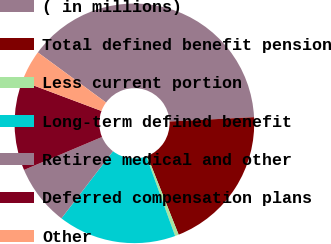Convert chart. <chart><loc_0><loc_0><loc_500><loc_500><pie_chart><fcel>( in millions)<fcel>Total defined benefit pension<fcel>Less current portion<fcel>Long-term defined benefit<fcel>Retiree medical and other<fcel>Deferred compensation plans<fcel>Other<nl><fcel>39.1%<fcel>19.8%<fcel>0.5%<fcel>15.94%<fcel>8.22%<fcel>12.08%<fcel>4.36%<nl></chart> 